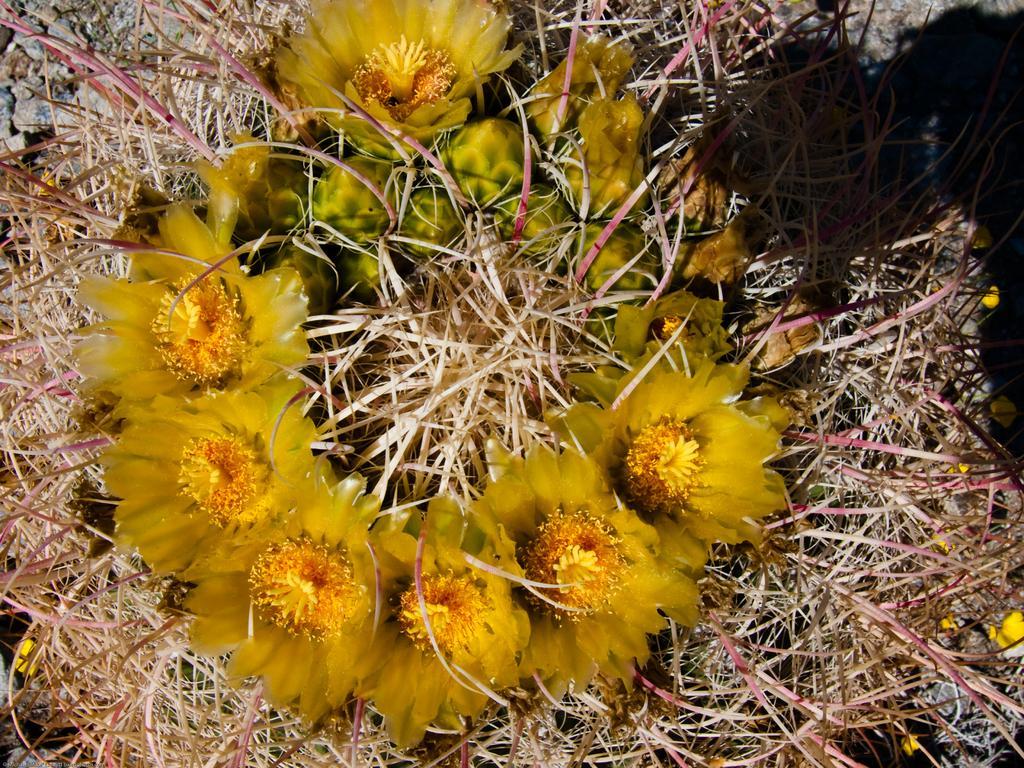Can you describe this image briefly? In the picture I can see some flowers which are yellow in color and there are some stones. 